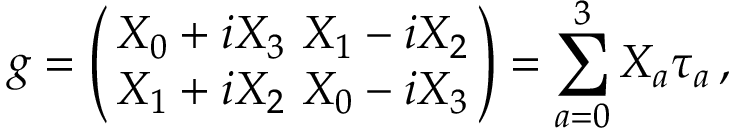Convert formula to latex. <formula><loc_0><loc_0><loc_500><loc_500>g = \left ( \, \begin{array} { c } { { X _ { 0 } + i X _ { 3 } \ X _ { 1 } - i X _ { 2 } } } \\ { { X _ { 1 } + i X _ { 2 } \ X _ { 0 } - i X _ { 3 } } } \end{array} \, \right ) = \sum _ { a = 0 } ^ { 3 } X _ { a } \tau _ { a } \, ,</formula> 